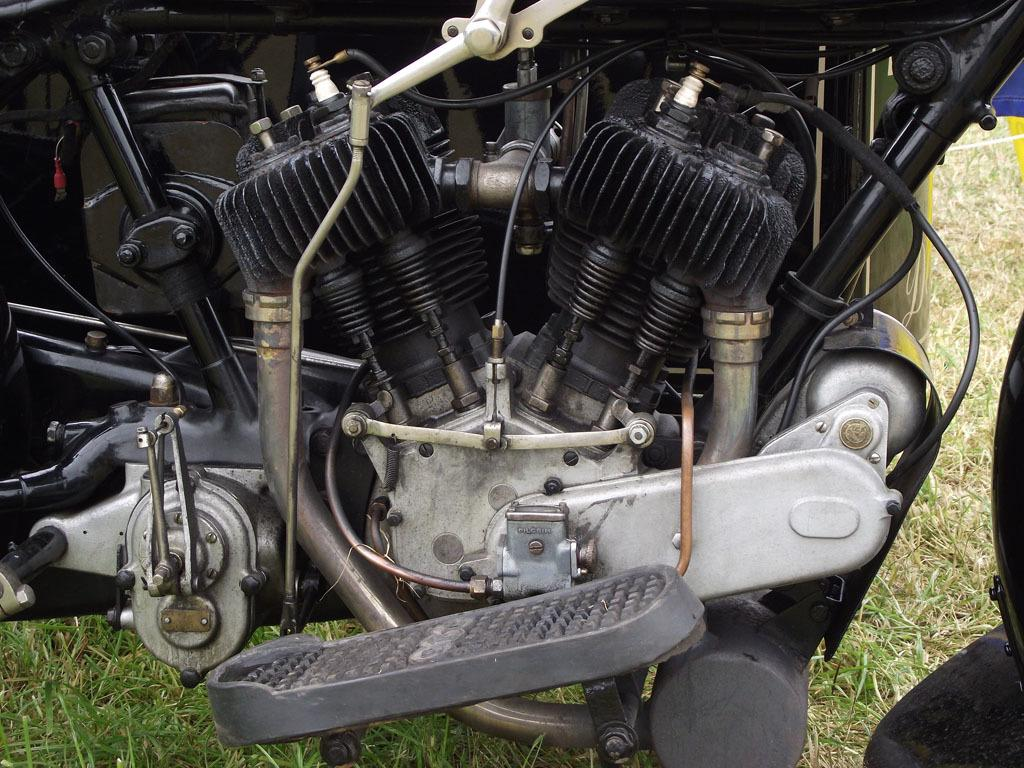What is the main object in the image? There is an engine in the image. What type of environment is visible in the image? There is grass visible in the image, suggesting an outdoor setting. What type of corn can be seen growing in the image? There is no corn present in the image; it only features an engine and grass. What letters are visible on the engine in the image? There is no mention of letters on the engine in the provided facts, so we cannot determine if any are visible. 